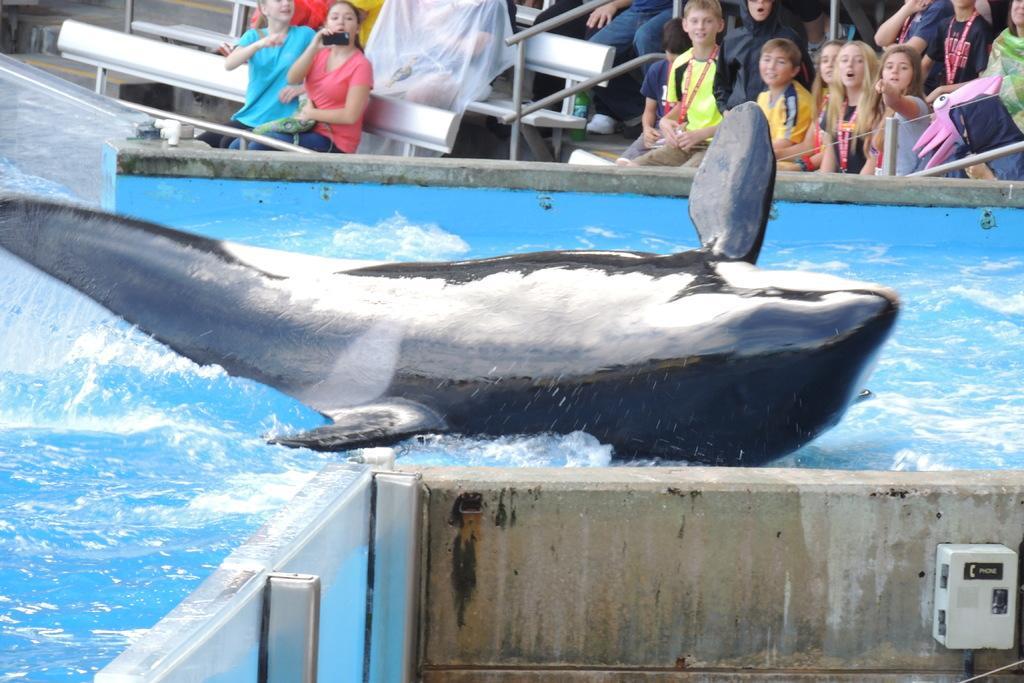Please provide a concise description of this image. In this picture I can see there is a dolphin in the water and there are few people sitting on the benches in the backdrop and the woman at left is holding a mobile and clicking pictures. There are few kids sitting at the right side. 